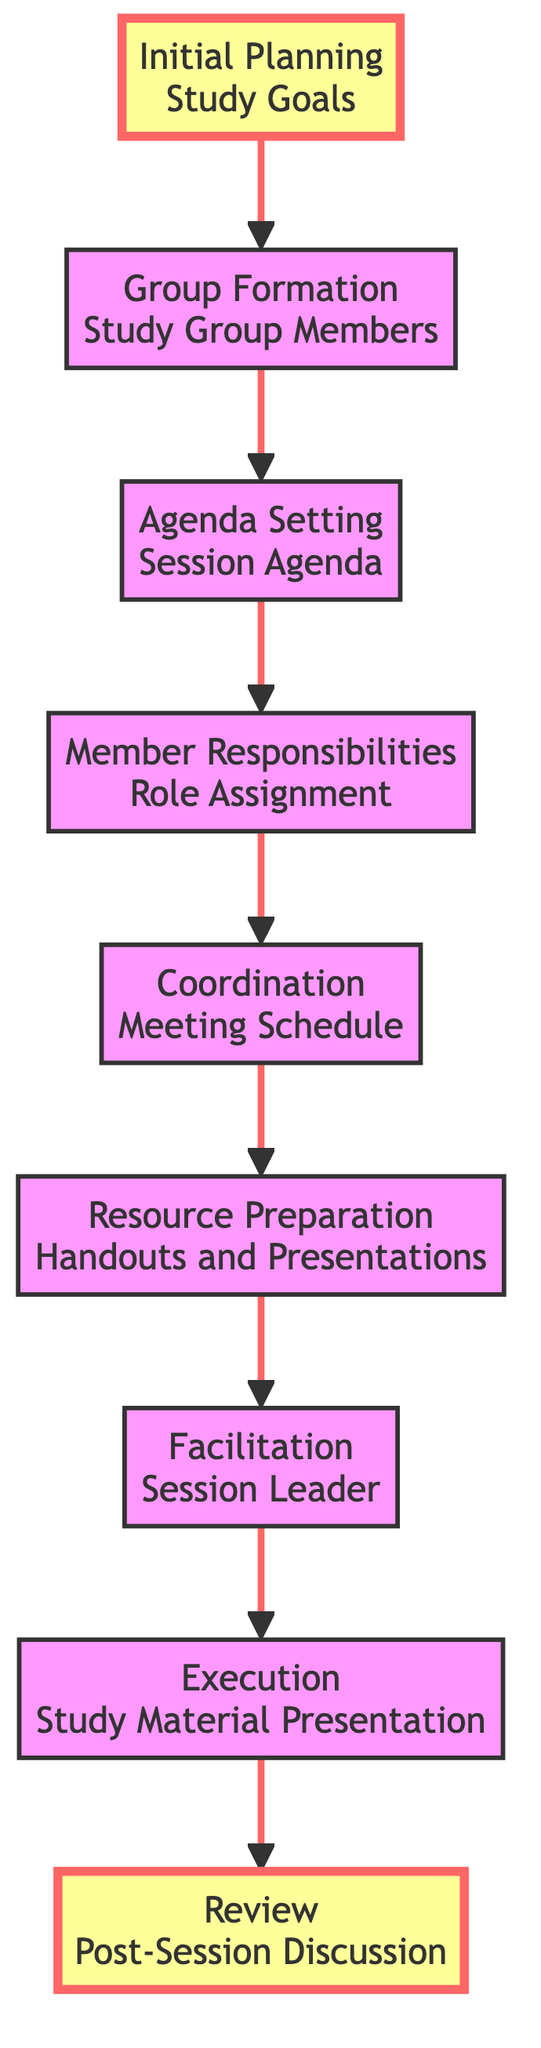what is the first step in the study group session planning process? The first step, as indicated at the bottom of the chart, is "Initial Planning" where the study goals are determined. This is the starting point for the flow.
Answer: Initial Planning what is the last step in the study group session process? The last step outlined in the flow chart is "Review," which encompasses summarizing key takeaways and addressing any remaining questions. It is positioned at the top of the flow.
Answer: Review how many nodes are present in the flow chart? By counting each unique step or element in the flow chart, we find there are a total of 9 nodes. Each node corresponds to a distinct stage in the planning and executing of a study group session.
Answer: 9 what follows the "Coordination" step in the flow? According to the sequence provided, after "Coordination," which involves finalizing meeting logistics, the next step is "Resource Preparation." This indicates the flow continues to prepare study materials after coordinating logistics.
Answer: Resource Preparation which node directly leads to "Execution"? The diagram shows that "Facilitation" directly leads into "Execution." This highlights that facilitating the session effectively is crucial before moving on to executing the session activities.
Answer: Facilitation what is the relationship between "Agenda Setting" and "Member Responsibilities"? "Agenda Setting" precedes "Member Responsibilities," indicating that setting the session agenda is essential before responsibilities can be assigned to group members. This shows a logical workflow where the agenda informs the assignment of roles.
Answer: Agenda Setting precedes Member Responsibilities how many steps are in the execution process after coordination? After the "Coordination" step, there are three subsequent steps in the execution process: "Resource Preparation," "Facilitation," and "Execution." Each of these steps builds on the previous to ensure a successful study group session.
Answer: 3 which element comes before "Group Formation"? The element that comes before "Group Formation" is "Initial Planning." This indicates that planning the study goals occurs prior to forming the study group.
Answer: Initial Planning what role does the "Facilitation" step play in the overall process? The "Facilitation" step plays a critical role as it ensures active participation and time management during the session. It is positioned right before execution, indicating its importance in making the execution effective.
Answer: Ensures active participation and manages time 